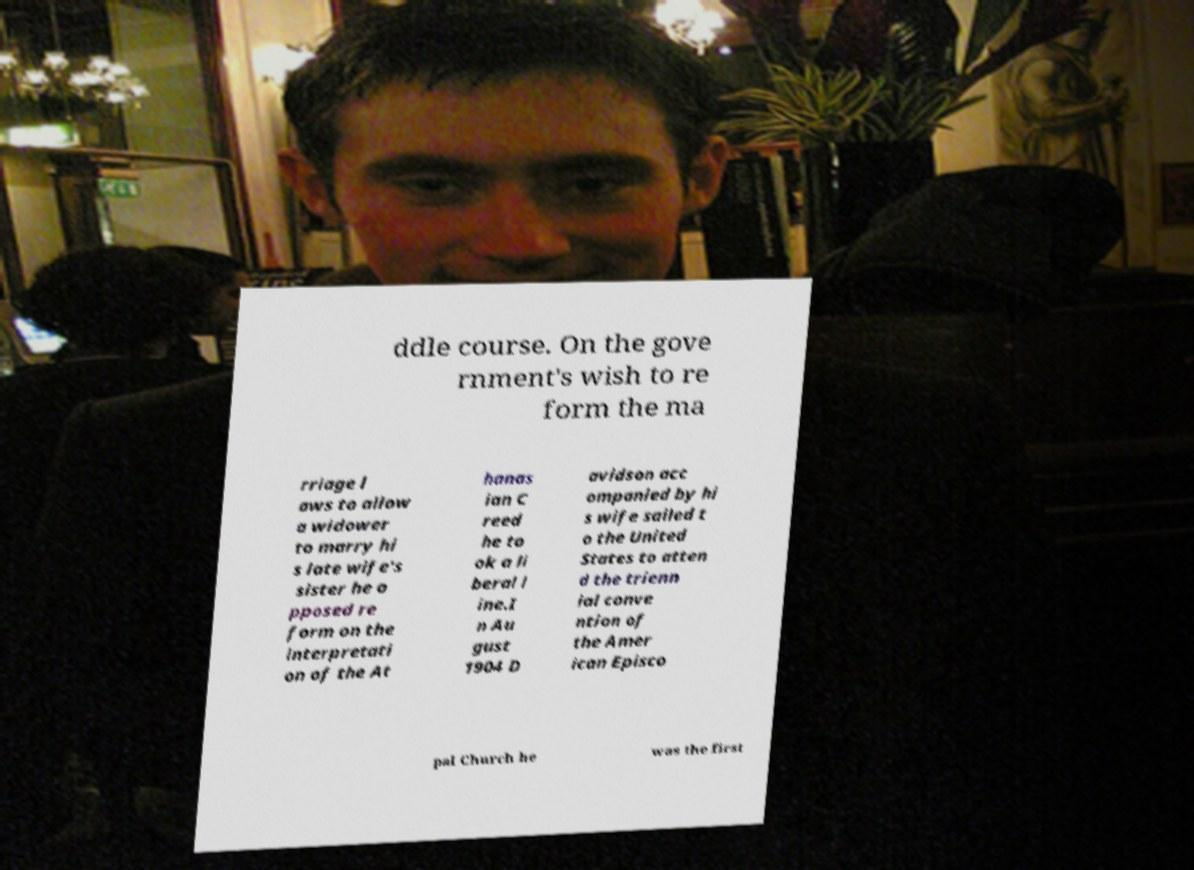There's text embedded in this image that I need extracted. Can you transcribe it verbatim? ddle course. On the gove rnment's wish to re form the ma rriage l aws to allow a widower to marry hi s late wife's sister he o pposed re form on the interpretati on of the At hanas ian C reed he to ok a li beral l ine.I n Au gust 1904 D avidson acc ompanied by hi s wife sailed t o the United States to atten d the trienn ial conve ntion of the Amer ican Episco pal Church he was the first 